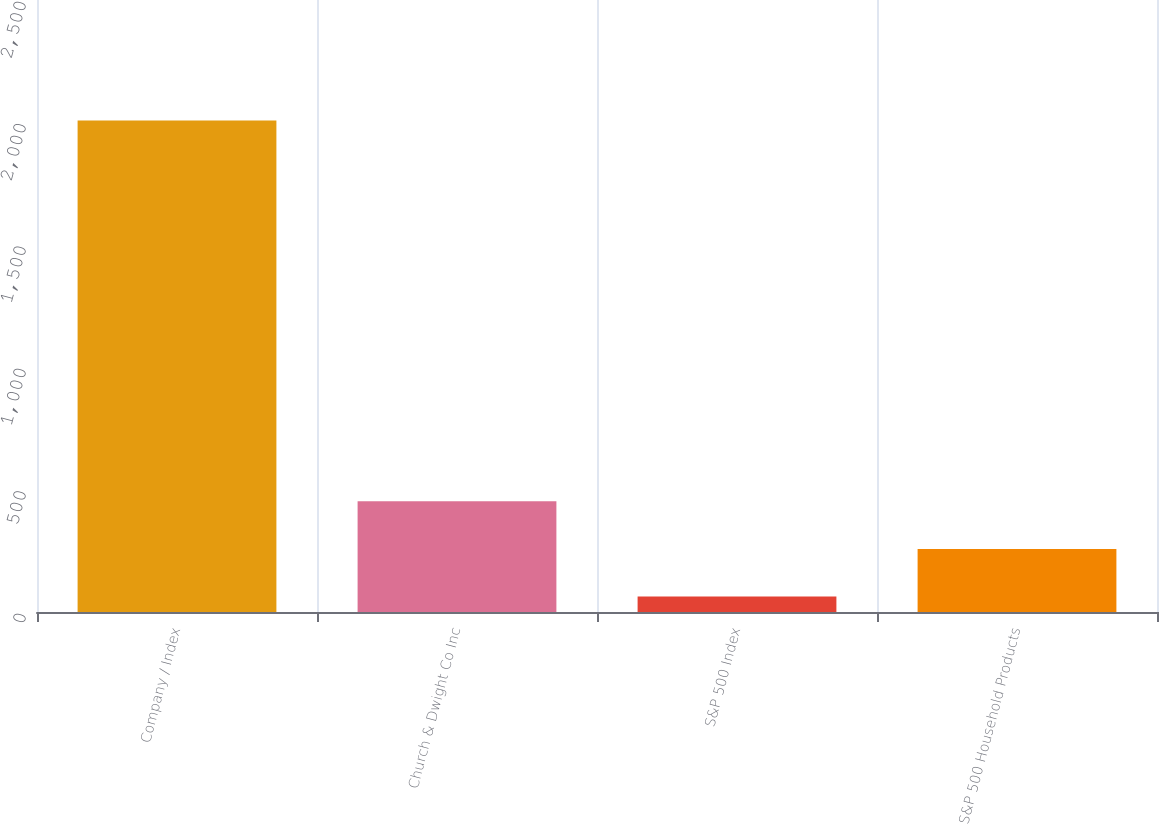<chart> <loc_0><loc_0><loc_500><loc_500><bar_chart><fcel>Company / Index<fcel>Church & Dwight Co Inc<fcel>S&P 500 Index<fcel>S&P 500 Household Products<nl><fcel>2008<fcel>452<fcel>63<fcel>257.5<nl></chart> 